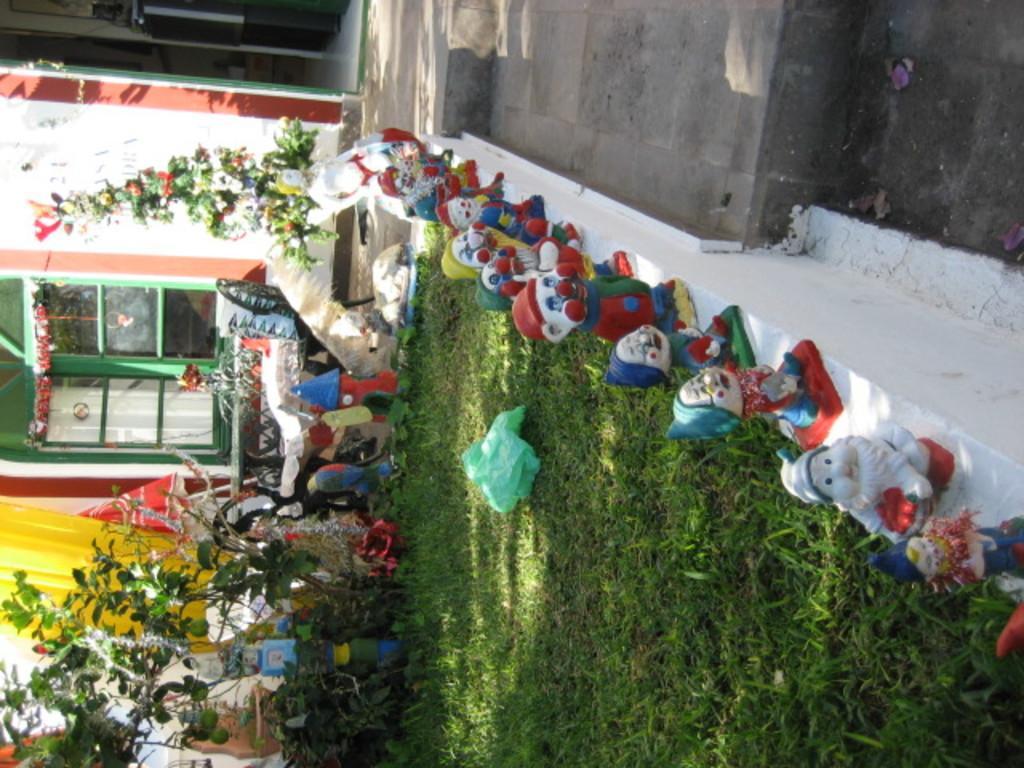Could you give a brief overview of what you see in this image? In this image we can see a wall. On the wall there are toys. On the ground there is grass. On the left side there is a building with windows. Also there are toys, plants and few other things. And there is green color thing on the grass. 